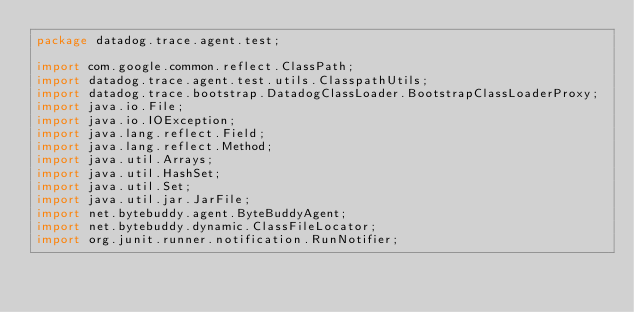Convert code to text. <code><loc_0><loc_0><loc_500><loc_500><_Java_>package datadog.trace.agent.test;

import com.google.common.reflect.ClassPath;
import datadog.trace.agent.test.utils.ClasspathUtils;
import datadog.trace.bootstrap.DatadogClassLoader.BootstrapClassLoaderProxy;
import java.io.File;
import java.io.IOException;
import java.lang.reflect.Field;
import java.lang.reflect.Method;
import java.util.Arrays;
import java.util.HashSet;
import java.util.Set;
import java.util.jar.JarFile;
import net.bytebuddy.agent.ByteBuddyAgent;
import net.bytebuddy.dynamic.ClassFileLocator;
import org.junit.runner.notification.RunNotifier;</code> 